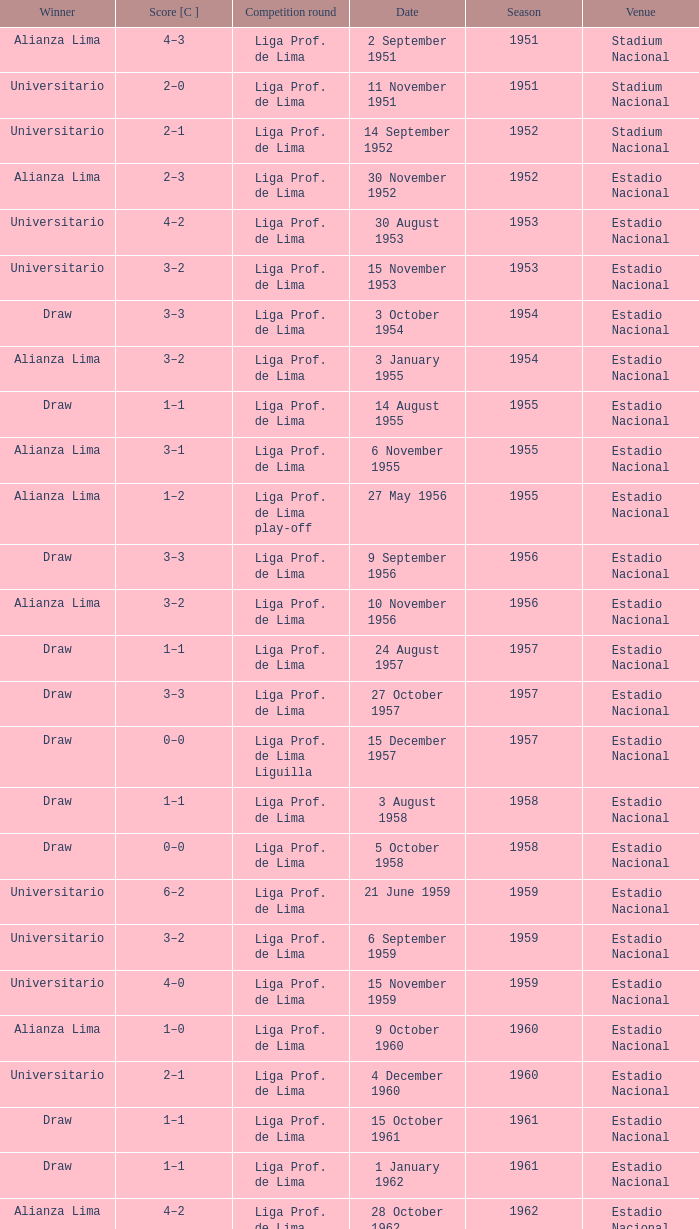Who was the winner on 15 December 1957? Draw. 